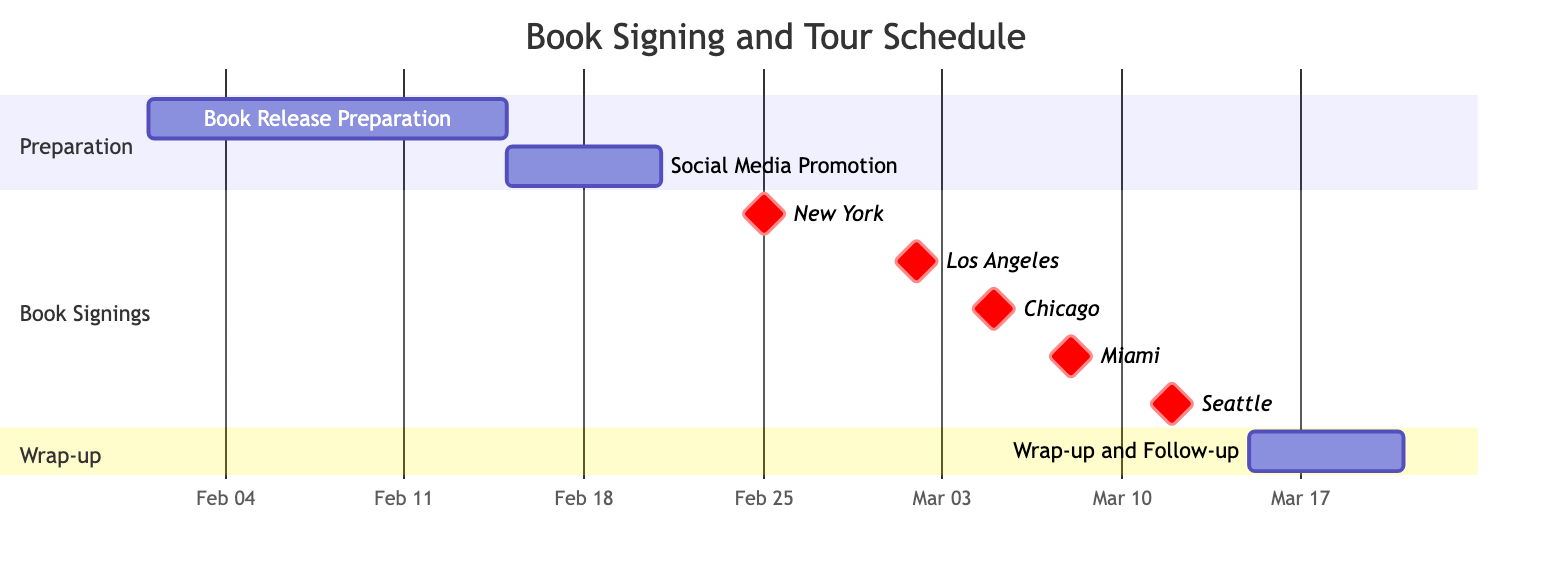What is the duration of the Book Release Preparation task? The task "Book Release Preparation" has an explicit duration mentioned in the diagram as "14 days."
Answer: 14 days When is the Book Signing Event in Los Angeles scheduled? The diagram shows that the "Book Signing Event in Los Angeles" is scheduled for "March 2, 2024."
Answer: March 2, 2024 How many book signing events are planned? By counting the number of distinct book signing events listed in the "Book Signings" section, we find there are five events: New York, Los Angeles, Chicago, Miami, and Seattle.
Answer: 5 What activity follows the Social Media Promotion? In the "Preparation" section, the "Social Media Promotion" task is followed by the "Book Signing Event in New York," as indicated by the task dependencies.
Answer: Book Signing Event in New York What is the latest date listed for any event in the Gantt chart? The latest event is "Wrap-up and Follow-up," which starts on "March 15, 2024," and lasts for six days, ending on "March 20, 2024," making it the latest date in the diagram.
Answer: March 20, 2024 Which location has a book signing event immediately before Miami? The diagram places "Book Signing Event in Chicago" directly before the "Book Signing Event in Miami," indicating that Chicago occurs immediately prior to Miami.
Answer: Chicago How many days are allocated for wrap-up and follow-up activities? The diagram specifies that "Wrap-up and Follow-up" is scheduled for a duration of "6 days," indicating the time allocated for these activities.
Answer: 6 days Which task is represented as a milestone in the diagram? The diagram indicates that all book signing events, including "New York," "Los Angeles," "Chicago," "Miami," and "Seattle," are marked as milestones, which typically represent significant points within the schedule.
Answer: New York, Los Angeles, Chicago, Miami, Seattle 